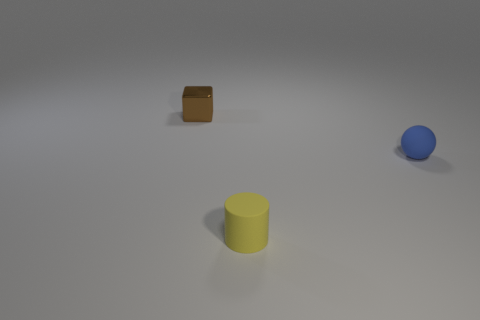Do the brown metal cube and the blue matte sphere have the same size? Yes, the brown metal cube and the blue matte sphere appear to have the same size when compared to one another in the image, which can be seen by observing the proportions and relative dimensions of each object. 